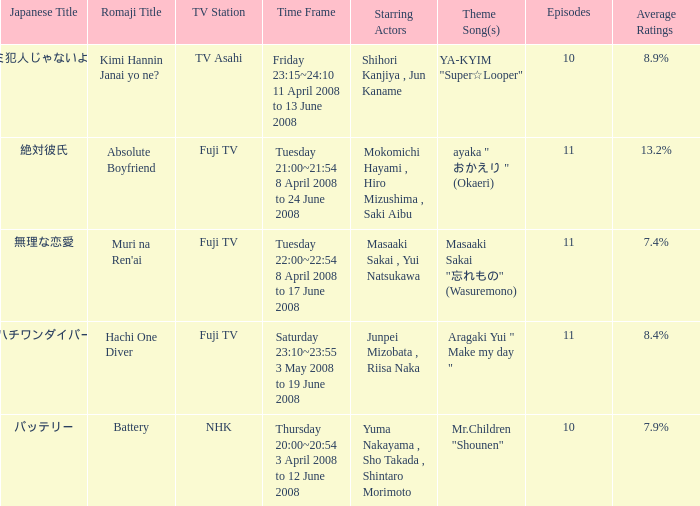In japanese, what are the title(s) for tv asahi? キミ犯人じゃないよね?. 